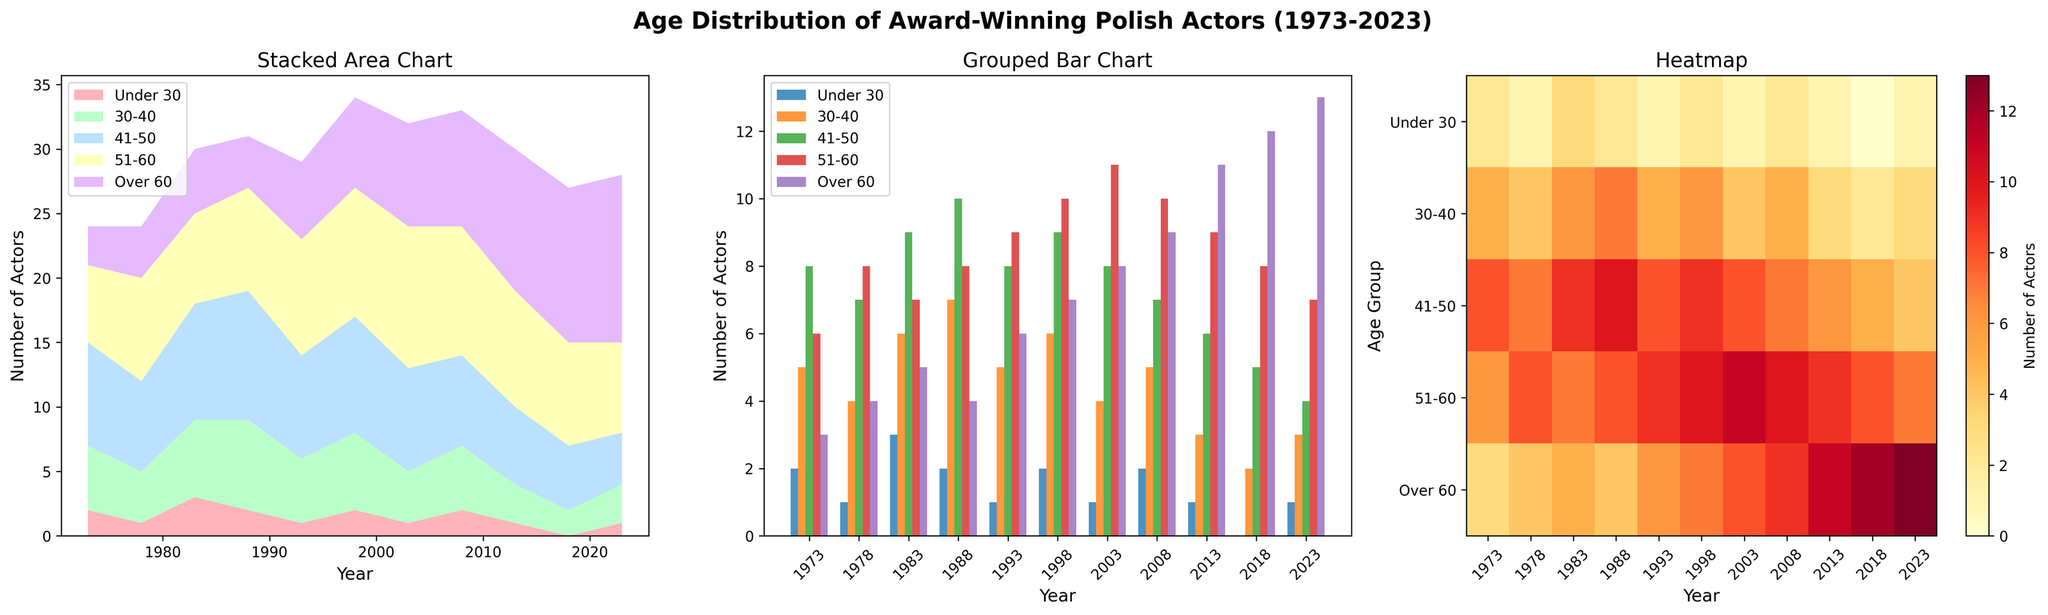What age group saw the most significant decrease in the number of actors from 1973 to 2023? To determine which group saw the most significant decrease, compare the number of actors in each age group in 1973 and 2023. The decrease can be calculated as 1973's value minus 2023's value.
Answer: Under 30 Which year had the highest number of actors over the age of 60? By examining the data across all three subplots (Stacked Area Chart, Grouped Bar Chart, and Heatmap), you can identify the highest value in the 'Over 60' category and note the corresponding year.
Answer: 2023 How does the number of actors aged 41-50 in 1993 compare to those aged 51-60 and over 60 in the same year? Compare the numerical values for the respective age groups in 1993 from the Stacked Area Chart or Grouped Bar Chart.
Answer: 8, 9, 6 What is the overall trend observed in the number of actors aged under 30 from 1973 to 2023? Analyze the trend by looking at how the 'Under 30' category changes over the years across the subplots, noting the general increase or decrease.
Answer: Decreasing Which age group first reaches a consistent count of over 10 actors, and in which year does this occur? Examine the data trends, particularly in the Grouped Bar Chart and Heatmap. Identify the first age group that surpasses and maintains a count of over 10 actors consistently.
Answer: Over 60 in 2013 What was the average number of actors aged 30-40 over the 50-year period? Calculate the average by summing all the values in the '30-40' category and dividing by the number of years. (5+4+6+7+5+6+4+5+3+2+3) / 11 = 4.545
Answer: 4.545 In which decade did actors aged 51-60 see the most significant growth? Evaluate the increase in numbers for the '51-60' category by comparing values at the start and end of each decade on the relevant subplots. Find the decade with the largest growth.
Answer: 1970s to 1980s Which age group had the smallest number of actors across all years, and in which year did this occur? Review the Heatmap to quickly identify the minimum value across all age groups and note the corresponding year.
Answer: Under 30 in 2018 